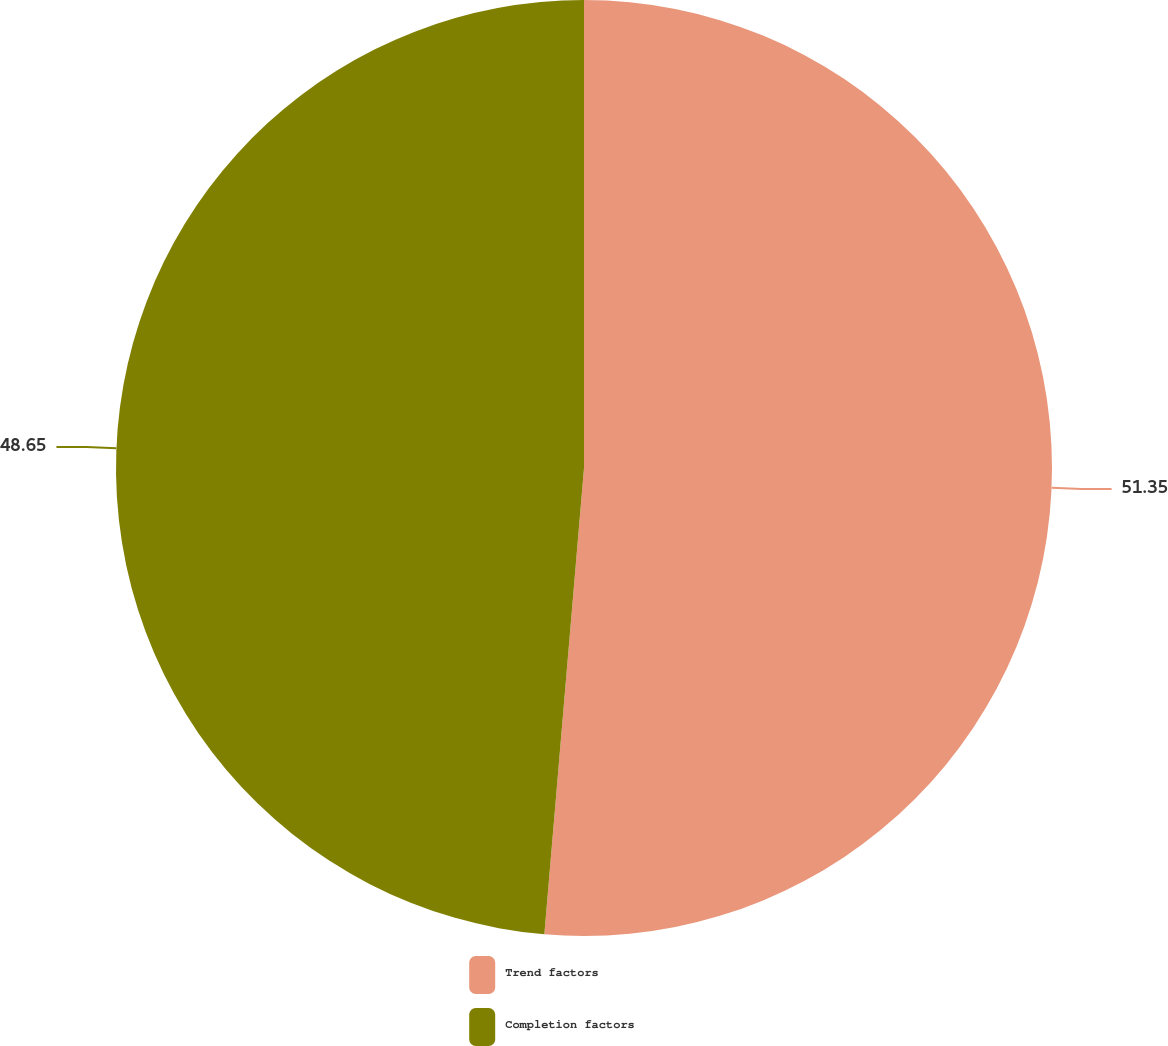<chart> <loc_0><loc_0><loc_500><loc_500><pie_chart><fcel>Trend factors<fcel>Completion factors<nl><fcel>51.35%<fcel>48.65%<nl></chart> 